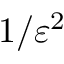Convert formula to latex. <formula><loc_0><loc_0><loc_500><loc_500>1 / \varepsilon ^ { 2 }</formula> 